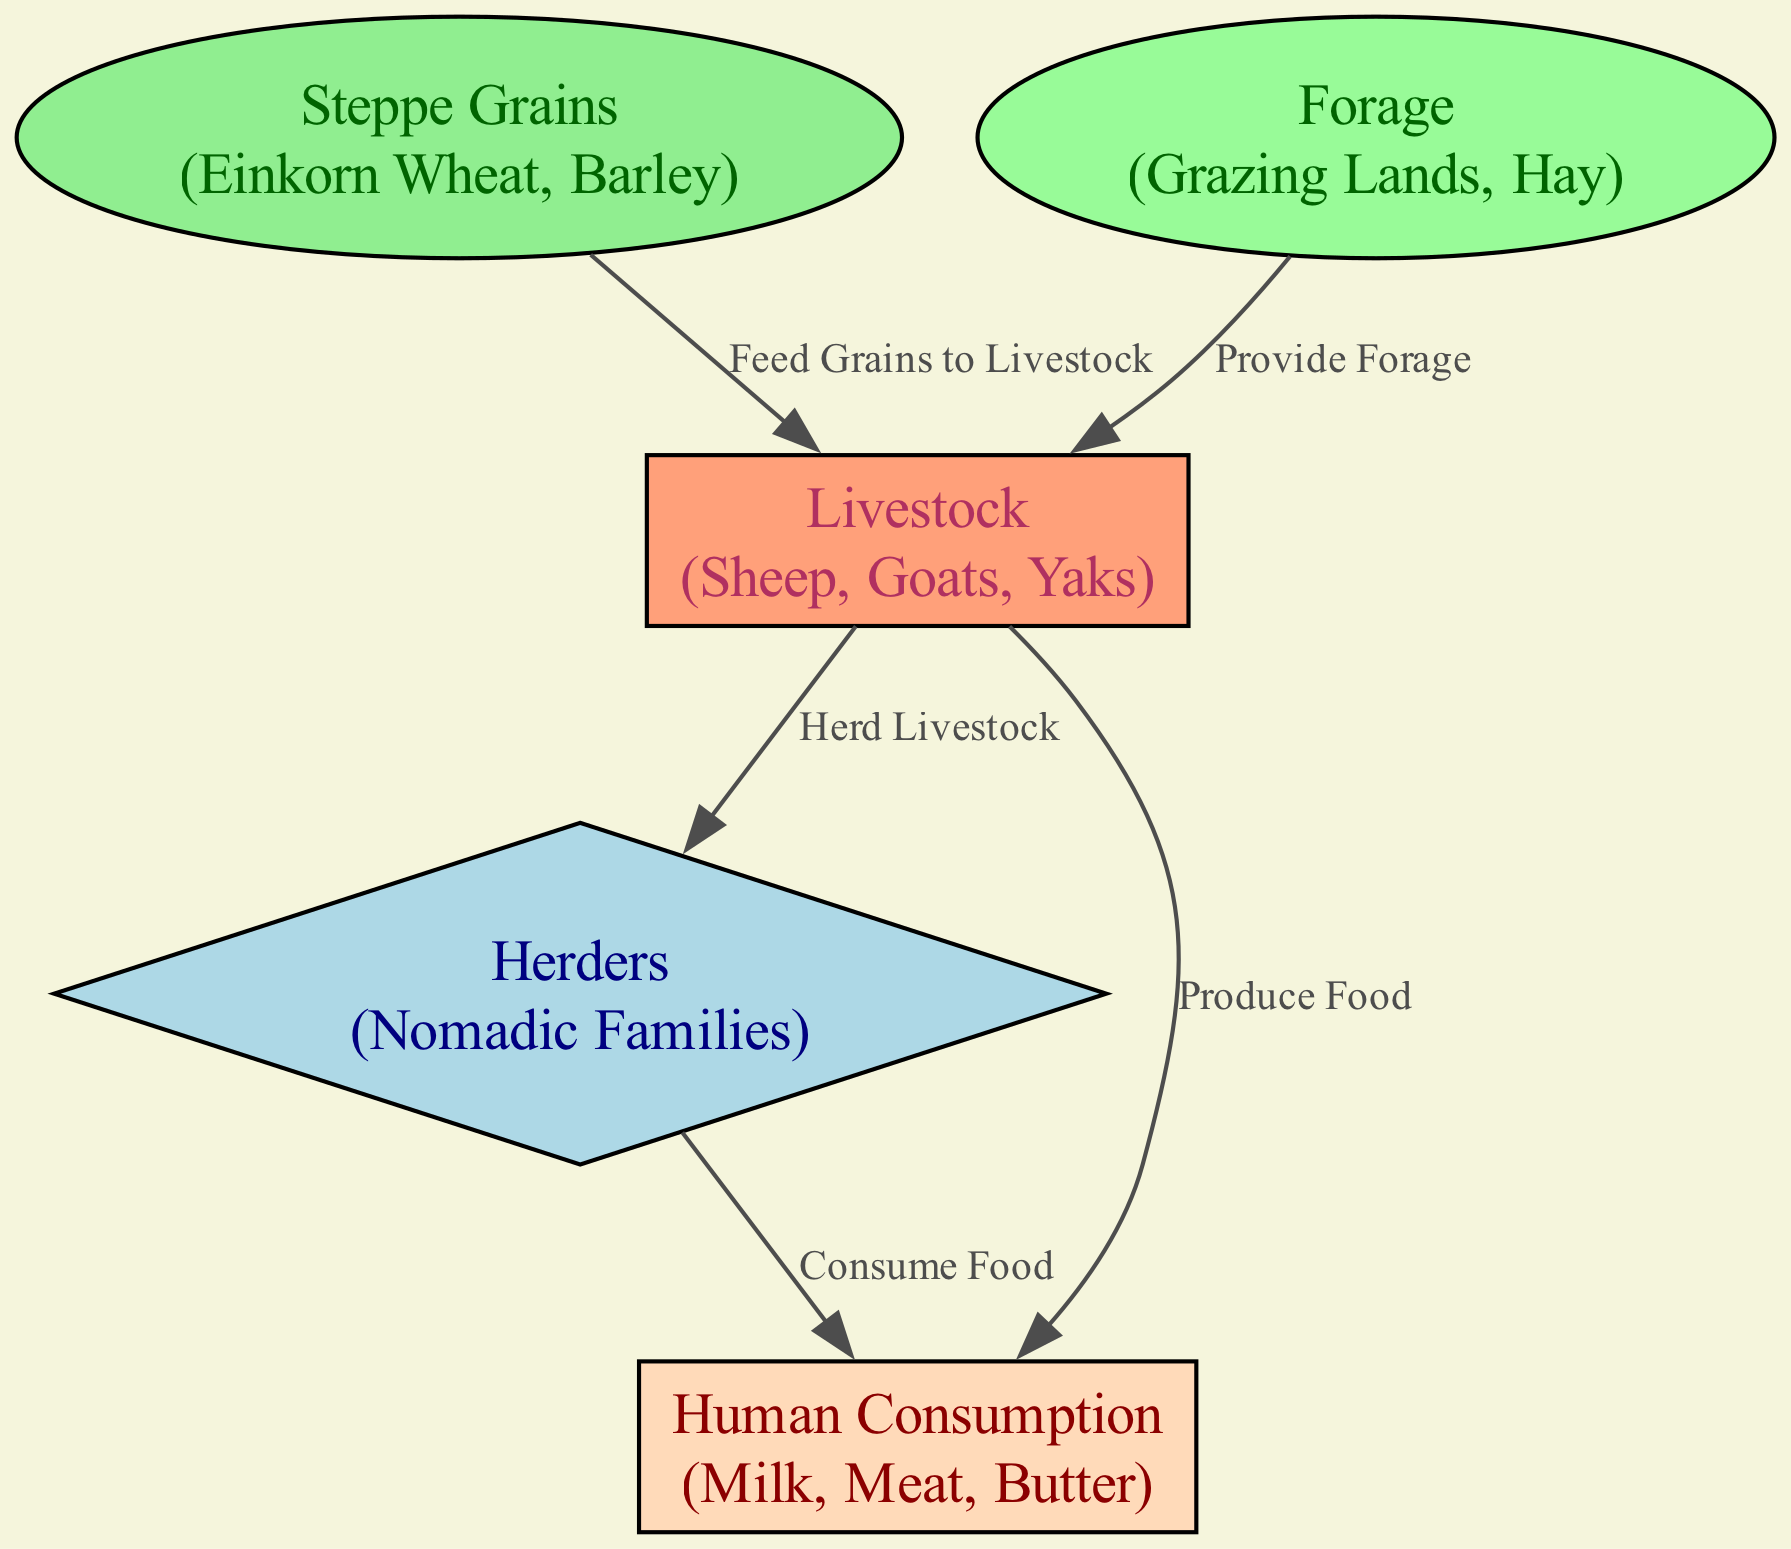What is the first node in the diagram? The first node in the diagram is "Steppe Grains," which represents the initial source of food in the food chain.
Answer: Steppe Grains How many nodes are present in the diagram? There are 5 nodes in the diagram, which are "Steppe Grains," "Forage," "Livestock," "Herders," and "Human Consumption."
Answer: 5 What does the "Livestock" node produce? The "Livestock" node produces food, specifically linked to human consumption, as indicated by the directed edge labeled "Produce Food."
Answer: Food Which nodes directly feed into the "Livestock" node? The nodes that directly feed into the "Livestock" node are "Steppe Grains" and "Forage," as both nodes have edges directed toward "Livestock."
Answer: Steppe Grains, Forage What is the relationship between "Herders" and "Human Consumption"? The relationship is that "Herders" consume food produced by "Livestock," as indicated by the directed edge labeled "Consume Food."
Answer: Consume Food How many edges are connected to the "Livestock" node? The "Livestock" node has three edges connected to it: from "Steppe Grains," from "Forage," and towards "Herders" and "Human Consumption."
Answer: 3 What type of family is represented in the "Herders" node? The "Herders" node represents "Nomadic Families," indicating the lifestyle of those who herd livestock in the steppes.
Answer: Nomadic Families What is the overall purpose of the food chain represented in this diagram? The overall purpose of the food chain is to illustrate the flow of energy and nutrients from "Steppe Grains" through "Livestock" to "Herders" and ultimately to "Human Consumption."
Answer: Food chain flow 